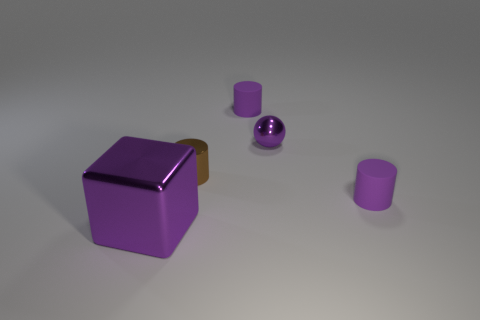Add 3 big purple shiny objects. How many objects exist? 8 Subtract all spheres. How many objects are left? 4 Add 4 gray metallic blocks. How many gray metallic blocks exist? 4 Subtract 0 blue cylinders. How many objects are left? 5 Subtract all large purple shiny things. Subtract all metal things. How many objects are left? 1 Add 5 tiny matte objects. How many tiny matte objects are left? 7 